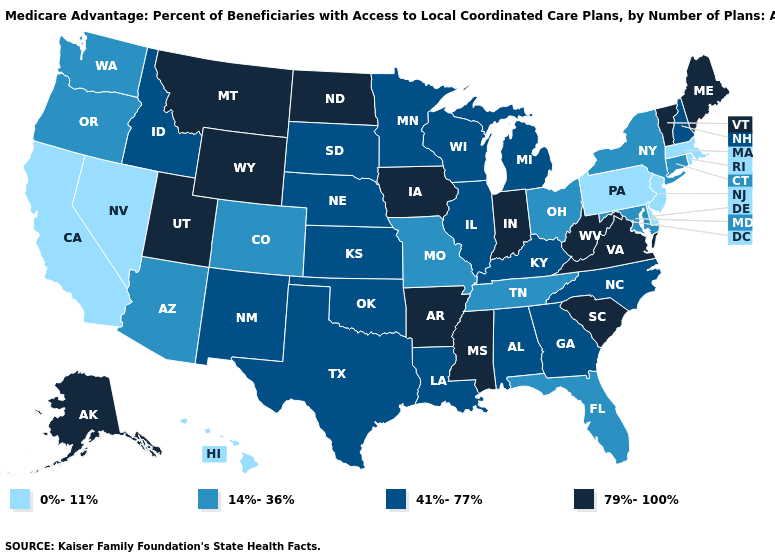Name the states that have a value in the range 41%-77%?
Be succinct. Alabama, Georgia, Idaho, Illinois, Kansas, Kentucky, Louisiana, Michigan, Minnesota, North Carolina, Nebraska, New Hampshire, New Mexico, Oklahoma, South Dakota, Texas, Wisconsin. Among the states that border Texas , does Arkansas have the highest value?
Answer briefly. Yes. What is the value of Arizona?
Keep it brief. 14%-36%. Among the states that border Iowa , which have the lowest value?
Concise answer only. Missouri. Name the states that have a value in the range 41%-77%?
Quick response, please. Alabama, Georgia, Idaho, Illinois, Kansas, Kentucky, Louisiana, Michigan, Minnesota, North Carolina, Nebraska, New Hampshire, New Mexico, Oklahoma, South Dakota, Texas, Wisconsin. What is the lowest value in the USA?
Short answer required. 0%-11%. Which states have the highest value in the USA?
Keep it brief. Alaska, Arkansas, Iowa, Indiana, Maine, Mississippi, Montana, North Dakota, South Carolina, Utah, Virginia, Vermont, West Virginia, Wyoming. Does the map have missing data?
Quick response, please. No. Among the states that border Oklahoma , does Colorado have the lowest value?
Quick response, please. Yes. Does Mississippi have the same value as Washington?
Give a very brief answer. No. Among the states that border Mississippi , which have the highest value?
Keep it brief. Arkansas. Name the states that have a value in the range 41%-77%?
Keep it brief. Alabama, Georgia, Idaho, Illinois, Kansas, Kentucky, Louisiana, Michigan, Minnesota, North Carolina, Nebraska, New Hampshire, New Mexico, Oklahoma, South Dakota, Texas, Wisconsin. Is the legend a continuous bar?
Short answer required. No. Which states have the lowest value in the Northeast?
Answer briefly. Massachusetts, New Jersey, Pennsylvania, Rhode Island. Does North Dakota have the highest value in the MidWest?
Short answer required. Yes. 